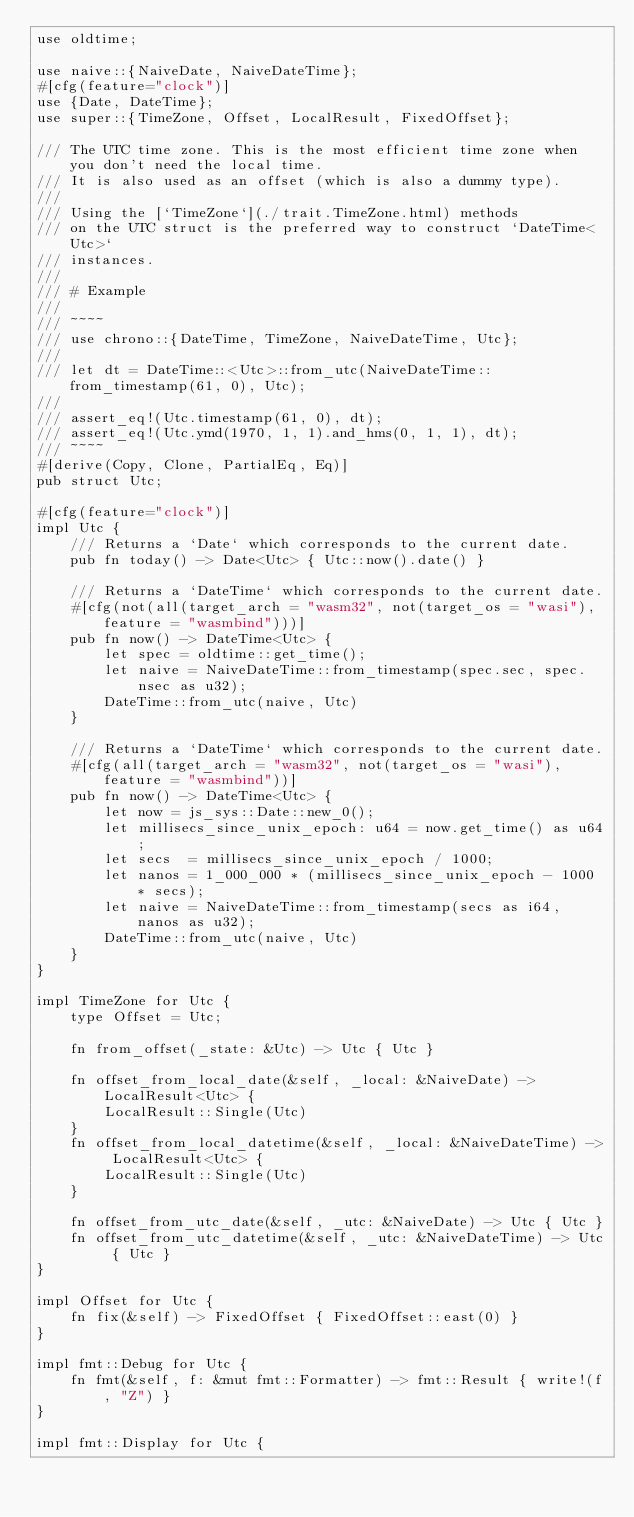<code> <loc_0><loc_0><loc_500><loc_500><_Rust_>use oldtime;

use naive::{NaiveDate, NaiveDateTime};
#[cfg(feature="clock")]
use {Date, DateTime};
use super::{TimeZone, Offset, LocalResult, FixedOffset};

/// The UTC time zone. This is the most efficient time zone when you don't need the local time.
/// It is also used as an offset (which is also a dummy type).
///
/// Using the [`TimeZone`](./trait.TimeZone.html) methods
/// on the UTC struct is the preferred way to construct `DateTime<Utc>`
/// instances.
///
/// # Example
///
/// ~~~~
/// use chrono::{DateTime, TimeZone, NaiveDateTime, Utc};
///
/// let dt = DateTime::<Utc>::from_utc(NaiveDateTime::from_timestamp(61, 0), Utc);
///
/// assert_eq!(Utc.timestamp(61, 0), dt);
/// assert_eq!(Utc.ymd(1970, 1, 1).and_hms(0, 1, 1), dt);
/// ~~~~
#[derive(Copy, Clone, PartialEq, Eq)]
pub struct Utc;

#[cfg(feature="clock")]
impl Utc {
    /// Returns a `Date` which corresponds to the current date.
    pub fn today() -> Date<Utc> { Utc::now().date() }

    /// Returns a `DateTime` which corresponds to the current date.
    #[cfg(not(all(target_arch = "wasm32", not(target_os = "wasi"), feature = "wasmbind")))]
    pub fn now() -> DateTime<Utc> {
        let spec = oldtime::get_time();
        let naive = NaiveDateTime::from_timestamp(spec.sec, spec.nsec as u32);
        DateTime::from_utc(naive, Utc)
    }

    /// Returns a `DateTime` which corresponds to the current date.
    #[cfg(all(target_arch = "wasm32", not(target_os = "wasi"), feature = "wasmbind"))]
    pub fn now() -> DateTime<Utc> {
        let now = js_sys::Date::new_0();
        let millisecs_since_unix_epoch: u64 = now.get_time() as u64;
        let secs  = millisecs_since_unix_epoch / 1000;
        let nanos = 1_000_000 * (millisecs_since_unix_epoch - 1000 * secs);
        let naive = NaiveDateTime::from_timestamp(secs as i64, nanos as u32);
        DateTime::from_utc(naive, Utc)
    }
}

impl TimeZone for Utc {
    type Offset = Utc;

    fn from_offset(_state: &Utc) -> Utc { Utc }

    fn offset_from_local_date(&self, _local: &NaiveDate) -> LocalResult<Utc> {
        LocalResult::Single(Utc)
    }
    fn offset_from_local_datetime(&self, _local: &NaiveDateTime) -> LocalResult<Utc> {
        LocalResult::Single(Utc)
    }

    fn offset_from_utc_date(&self, _utc: &NaiveDate) -> Utc { Utc }
    fn offset_from_utc_datetime(&self, _utc: &NaiveDateTime) -> Utc { Utc }
}

impl Offset for Utc {
    fn fix(&self) -> FixedOffset { FixedOffset::east(0) }
}

impl fmt::Debug for Utc {
    fn fmt(&self, f: &mut fmt::Formatter) -> fmt::Result { write!(f, "Z") }
}

impl fmt::Display for Utc {</code> 